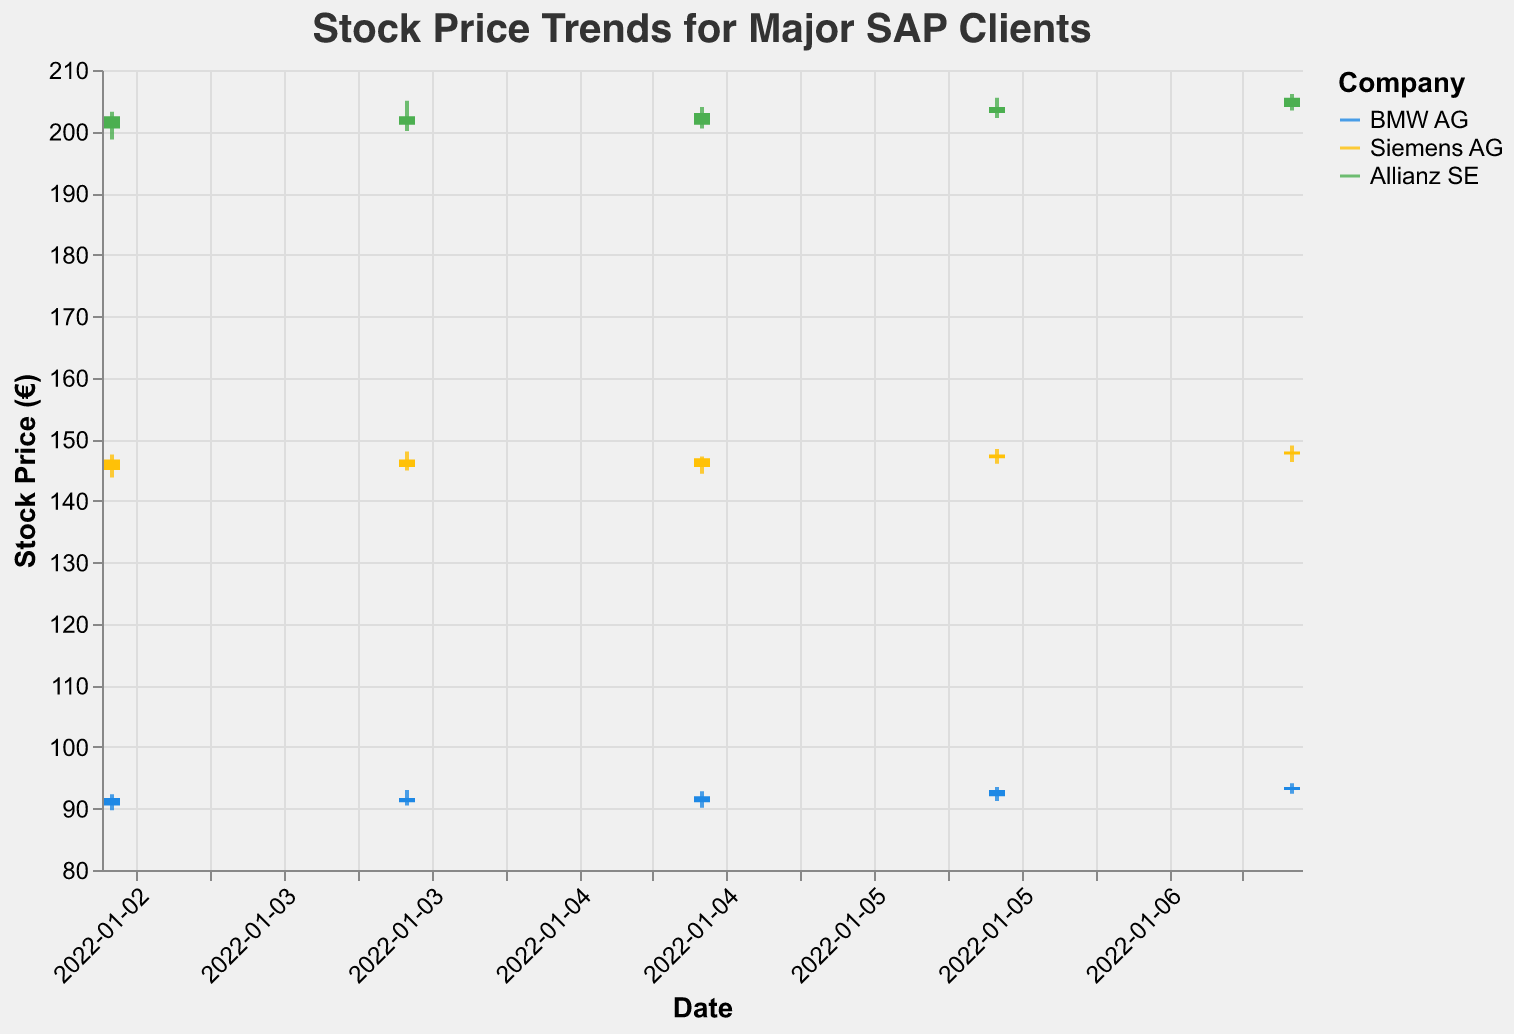What is the closing price of BMW AG on January 3, 2022? By looking at the candlestick for BMW AG on January 3, you can find the closing price at the top endpoint of the bar part of the candlestick.
Answer: 91.7 What is the difference between the opening and closing price for Siemens AG on January 4, 2022? The opening price for Siemens AG on January 4 is 146.7, and the closing price is 145.5. The difference is 146.7 - 145.5.
Answer: 1.2 Which company experienced the highest volume of trade on January 7, 2022? On January 7, Siemens AG had a trading volume of 1,580,000 which is higher compared to BMW AG's 1,100,000 and Allianz SE's 970,000.
Answer: Siemens AG What was the highest stock price (High) for Allianz SE over the given period? Examine the High prices of Allianz SE: 203.2, 205.0, 204.0, 205.5, 206.1. The highest value is 206.1.
Answer: 206.1 How did BMW AG's stock price trend from January 3, 2022, to January 7, 2022? BMW AG's stock prices were: 90.5 (open) to 91.7 (close) on January 3, 91.7 to 91.0 on January 4, 91.0 to 92.0 on January 5, 92.0 to 93.0 on January 6, and 93.0 to 93.5 on January 7. General trend shows an increase from 90.5 to 93.5.
Answer: Increasing What is the average closing price for Siemens AG over the given period? Siemens AG's closing prices are: 146.7, 145.5, 146.9, 147.5, 148.0. Calculate the average by summing these values and dividing by 5: (146.7 + 145.5 + 146.9 + 147.5 + 148.0) / 5.
Answer: 146.92 Which day saw the highest increase in closing price for Allianz SE? Compare the consecutive days’ closing prices for Allianz SE. The increase is highest from January 4 to January 5: 201.1 to 203.0 (1.9).
Answer: January 5, 2022 Which company's stock price has the least volatility in terms of the range (High - Low) over these dates? Calculate the average range for each company. BMW AG: (2.6 + 2.5 + 2.7 + 2.3 + 2.7)/5 = 2.56; Siemens AG: (3.7 + 3.1 + 2.8 + 2.4 + 2.7)/5 = 2.94; Allianz SE: (4.5 + 4.9 + 4.0 + 3.3 + 2.7)/5 = 3.88. BMW AG has the least volatility.
Answer: BMW AG What was the closing stock price for BMW AG on January 6, 2022? Observe the candlestick for BMW AG on January 6 for the closing price at the top endpoint of the bar part.
Answer: 93.0 